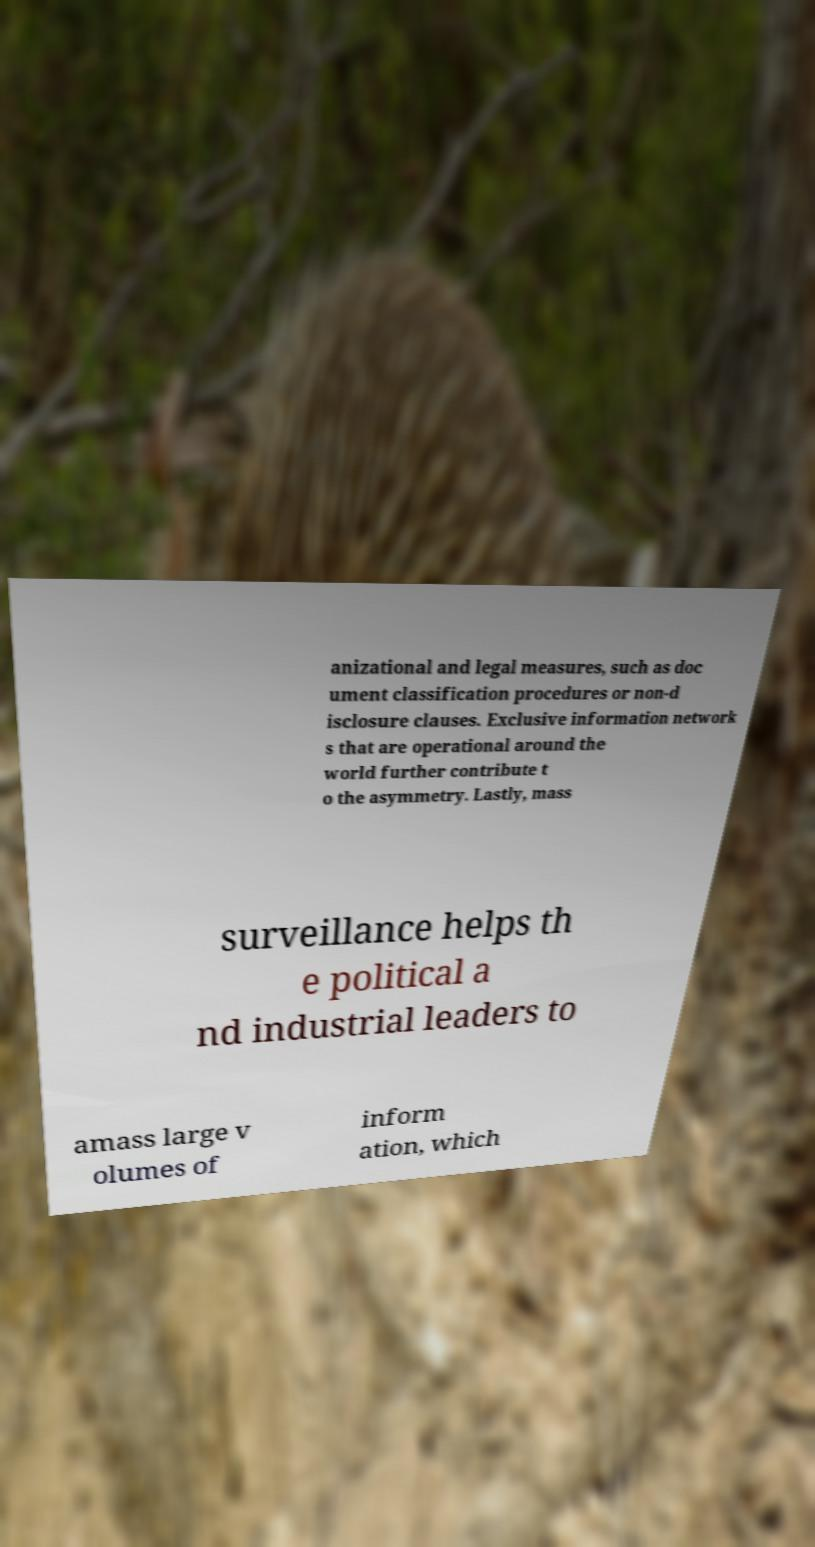Can you read and provide the text displayed in the image?This photo seems to have some interesting text. Can you extract and type it out for me? anizational and legal measures, such as doc ument classification procedures or non-d isclosure clauses. Exclusive information network s that are operational around the world further contribute t o the asymmetry. Lastly, mass surveillance helps th e political a nd industrial leaders to amass large v olumes of inform ation, which 